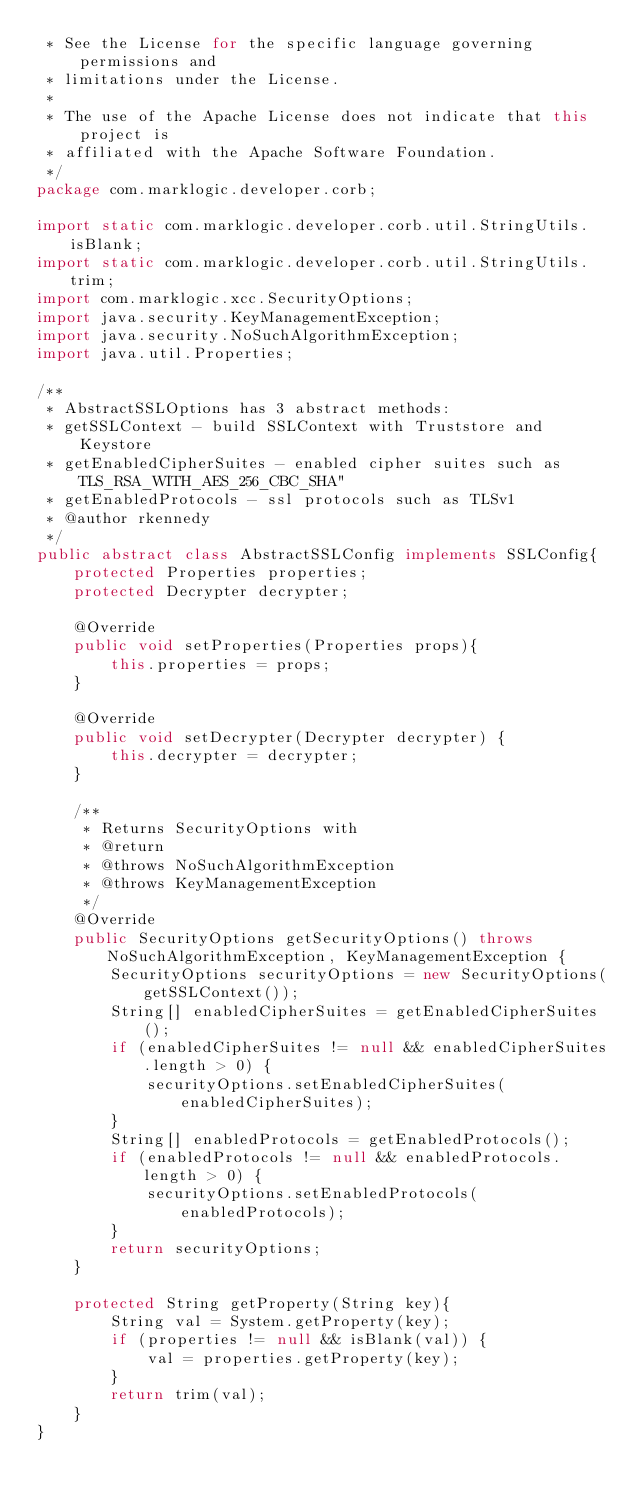Convert code to text. <code><loc_0><loc_0><loc_500><loc_500><_Java_> * See the License for the specific language governing permissions and
 * limitations under the License.
 *
 * The use of the Apache License does not indicate that this project is
 * affiliated with the Apache Software Foundation.
 */
package com.marklogic.developer.corb;

import static com.marklogic.developer.corb.util.StringUtils.isBlank;
import static com.marklogic.developer.corb.util.StringUtils.trim;
import com.marklogic.xcc.SecurityOptions;
import java.security.KeyManagementException;
import java.security.NoSuchAlgorithmException;
import java.util.Properties;

/**
 * AbstractSSLOptions has 3 abstract methods:
 * getSSLContext - build SSLContext with Truststore and Keystore
 * getEnabledCipherSuites - enabled cipher suites such as TLS_RSA_WITH_AES_256_CBC_SHA"
 * getEnabledProtocols - ssl protocols such as TLSv1
 * @author rkennedy
 */
public abstract class AbstractSSLConfig implements SSLConfig{
	protected Properties properties;
	protected Decrypter decrypter;

    @Override
	public void setProperties(Properties props){
		this.properties = props;
	}

    @Override
	public void setDecrypter(Decrypter decrypter) {
		this.decrypter = decrypter;
	}

	/**
	 * Returns SecurityOptions with
	 * @return
	 * @throws NoSuchAlgorithmException
	 * @throws KeyManagementException
	 */
    @Override
	public SecurityOptions getSecurityOptions() throws NoSuchAlgorithmException, KeyManagementException {
		SecurityOptions securityOptions = new SecurityOptions(getSSLContext());
		String[] enabledCipherSuites = getEnabledCipherSuites();
		if (enabledCipherSuites != null && enabledCipherSuites.length > 0) {
			securityOptions.setEnabledCipherSuites(enabledCipherSuites);
		}
		String[] enabledProtocols = getEnabledProtocols();
		if (enabledProtocols != null && enabledProtocols.length > 0) {
			securityOptions.setEnabledProtocols(enabledProtocols);
		}
		return securityOptions;
	}

	protected String getProperty(String key){
		String val = System.getProperty(key);
		if (properties != null && isBlank(val)) {
			val = properties.getProperty(key);
		}
		return trim(val);
	}
}
</code> 